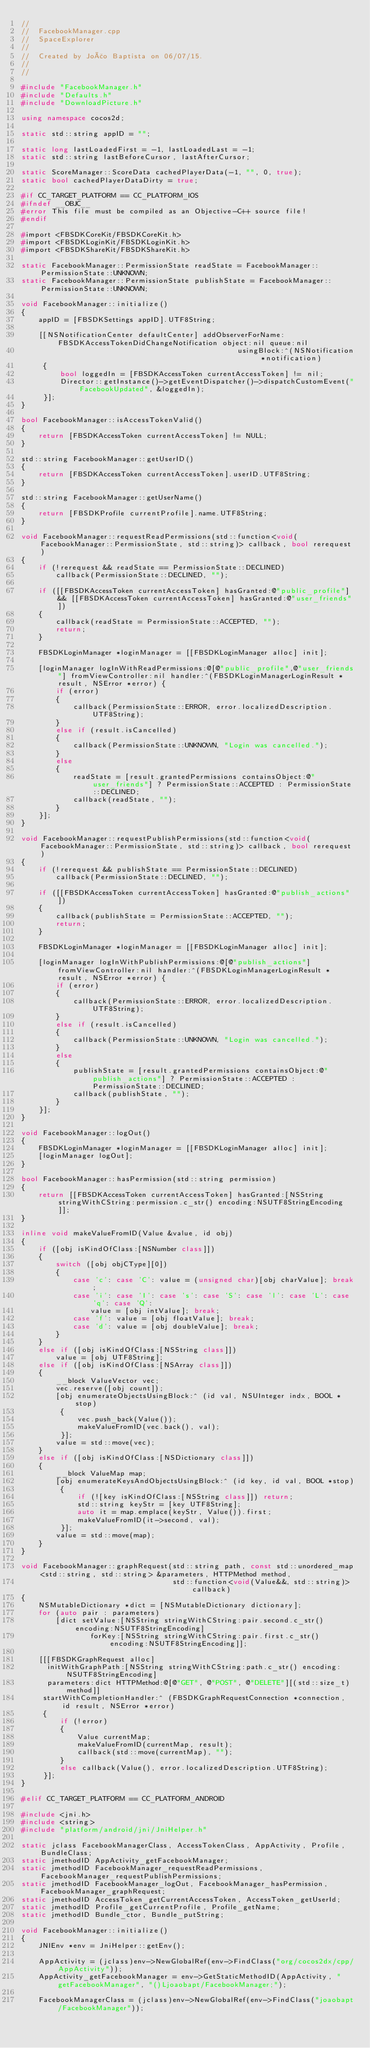Convert code to text. <code><loc_0><loc_0><loc_500><loc_500><_C++_>//
//  FacebookManager.cpp
//  SpaceExplorer
//
//  Created by João Baptista on 06/07/15.
//
//

#include "FacebookManager.h"
#include "Defaults.h"
#include "DownloadPicture.h"

using namespace cocos2d;

static std::string appID = "";

static long lastLoadedFirst = -1, lastLoadedLast = -1;
static std::string lastBeforeCursor, lastAfterCursor;

static ScoreManager::ScoreData cachedPlayerData(-1, "", 0, true);
static bool cachedPlayerDataDirty = true;

#if CC_TARGET_PLATFORM == CC_PLATFORM_IOS
#ifndef __OBJC__
#error This file must be compiled as an Objective-C++ source file!
#endif

#import <FBSDKCoreKit/FBSDKCoreKit.h>
#import <FBSDKLoginKit/FBSDKLoginKit.h>
#import <FBSDKShareKit/FBSDKShareKit.h>

static FacebookManager::PermissionState readState = FacebookManager::PermissionState::UNKNOWN;
static FacebookManager::PermissionState publishState = FacebookManager::PermissionState::UNKNOWN;

void FacebookManager::initialize()
{
    appID = [FBSDKSettings appID].UTF8String;
    
    [[NSNotificationCenter defaultCenter] addObserverForName:FBSDKAccessTokenDidChangeNotification object:nil queue:nil
                                                  usingBlock:^(NSNotification *notification)
     {
         bool loggedIn = [FBSDKAccessToken currentAccessToken] != nil;
         Director::getInstance()->getEventDispatcher()->dispatchCustomEvent("FacebookUpdated", &loggedIn);
     }];
}

bool FacebookManager::isAccessTokenValid()
{
    return [FBSDKAccessToken currentAccessToken] != NULL;
}

std::string FacebookManager::getUserID()
{
    return [FBSDKAccessToken currentAccessToken].userID.UTF8String;
}

std::string FacebookManager::getUserName()
{
    return [FBSDKProfile currentProfile].name.UTF8String;
}

void FacebookManager::requestReadPermissions(std::function<void(FacebookManager::PermissionState, std::string)> callback, bool rerequest)
{
    if (!rerequest && readState == PermissionState::DECLINED)
        callback(PermissionState::DECLINED, "");
    
    if ([[FBSDKAccessToken currentAccessToken] hasGranted:@"public_profile"] && [[FBSDKAccessToken currentAccessToken] hasGranted:@"user_friends"])
    {
        callback(readState = PermissionState::ACCEPTED, "");
        return;
    }
    
    FBSDKLoginManager *loginManager = [[FBSDKLoginManager alloc] init];
    
    [loginManager logInWithReadPermissions:@[@"public_profile",@"user_friends"] fromViewController:nil handler:^(FBSDKLoginManagerLoginResult *result, NSError *error) {
        if (error)
        {
            callback(PermissionState::ERROR, error.localizedDescription.UTF8String);
        }
        else if (result.isCancelled)
        {
            callback(PermissionState::UNKNOWN, "Login was cancelled.");
        }
        else
        {
            readState = [result.grantedPermissions containsObject:@"user_friends"] ? PermissionState::ACCEPTED : PermissionState::DECLINED;
            callback(readState, "");
        }
    }];
}

void FacebookManager::requestPublishPermissions(std::function<void(FacebookManager::PermissionState, std::string)> callback, bool rerequest)
{
    if (!rerequest && publishState == PermissionState::DECLINED)
        callback(PermissionState::DECLINED, "");
    
    if ([[FBSDKAccessToken currentAccessToken] hasGranted:@"publish_actions"])
    {
        callback(publishState = PermissionState::ACCEPTED, "");
        return;
    }
    
    FBSDKLoginManager *loginManager = [[FBSDKLoginManager alloc] init];
    
    [loginManager logInWithPublishPermissions:@[@"publish_actions"] fromViewController:nil handler:^(FBSDKLoginManagerLoginResult *result, NSError *error) {
        if (error)
        {
            callback(PermissionState::ERROR, error.localizedDescription.UTF8String);
        }
        else if (result.isCancelled)
        {
            callback(PermissionState::UNKNOWN, "Login was cancelled.");
        }
        else
        {
            publishState = [result.grantedPermissions containsObject:@"publish_actions"] ? PermissionState::ACCEPTED : PermissionState::DECLINED;
            callback(publishState, "");
        }
    }];
}

void FacebookManager::logOut()
{
    FBSDKLoginManager *loginManager = [[FBSDKLoginManager alloc] init];
    [loginManager logOut];
}

bool FacebookManager::hasPermission(std::string permission)
{
    return [[FBSDKAccessToken currentAccessToken] hasGranted:[NSString stringWithCString:permission.c_str() encoding:NSUTF8StringEncoding]];
}

inline void makeValueFromID(Value &value, id obj)
{
    if ([obj isKindOfClass:[NSNumber class]])
    {
        switch ([obj objCType][0])
        {
            case 'c': case 'C': value = (unsigned char)[obj charValue]; break;
            case 'i': case 'I': case 's': case 'S': case 'l': case 'L': case 'q': case 'Q':
                value = [obj intValue]; break;
            case 'f': value = [obj floatValue]; break;
            case 'd': value = [obj doubleValue]; break;
        }
    }
    else if ([obj isKindOfClass:[NSString class]])
        value = [obj UTF8String];
    else if ([obj isKindOfClass:[NSArray class]])
    {
        __block ValueVector vec;
        vec.reserve([obj count]);
        [obj enumerateObjectsUsingBlock:^ (id val, NSUInteger indx, BOOL *stop)
         {
			 vec.push_back(Value());
             makeValueFromID(vec.back(), val);
         }];
        value = std::move(vec);
    }
    else if ([obj isKindOfClass:[NSDictionary class]])
    {
        __block ValueMap map;
        [obj enumerateKeysAndObjectsUsingBlock:^ (id key, id val, BOOL *stop)
         {
             if (![key isKindOfClass:[NSString class]]) return;
             std::string keyStr = [key UTF8String];
             auto it = map.emplace(keyStr, Value()).first;
             makeValueFromID(it->second, val);
         }];
        value = std::move(map);
    }
}

void FacebookManager::graphRequest(std::string path, const std::unordered_map<std::string, std::string> &parameters, HTTPMethod method,
                                   std::function<void(Value&&, std::string)> callback)
{
    NSMutableDictionary *dict = [NSMutableDictionary dictionary];
    for (auto pair : parameters)
        [dict setValue:[NSString stringWithCString:pair.second.c_str() encoding:NSUTF8StringEncoding]
                forKey:[NSString stringWithCString:pair.first.c_str() encoding:NSUTF8StringEncoding]];
    
    [[[FBSDKGraphRequest alloc]
      initWithGraphPath:[NSString stringWithCString:path.c_str() encoding:NSUTF8StringEncoding]
      parameters:dict HTTPMethod:@[@"GET", @"POST", @"DELETE"][(std::size_t)method]]
     startWithCompletionHandler:^ (FBSDKGraphRequestConnection *connection, id result, NSError *error)
     {
         if (!error)
         {
             Value currentMap;
             makeValueFromID(currentMap, result);
             callback(std::move(currentMap), "");
         }
         else callback(Value(), error.localizedDescription.UTF8String);
     }];
}

#elif CC_TARGET_PLATFORM == CC_PLATFORM_ANDROID

#include <jni.h>
#include <string>
#include "platform/android/jni/JniHelper.h"

static jclass FacebookManagerClass, AccessTokenClass, AppActivity, Profile, BundleClass;
static jmethodID AppActivity_getFacebookManager;
static jmethodID FacebookManager_requestReadPermissions, FacebookManager_requestPublishPermissions;
static jmethodID FacebookManager_logOut, FacebookManager_hasPermission, FacebookManager_graphRequest;
static jmethodID AccessToken_getCurrentAccessToken, AccessToken_getUserId;
static jmethodID Profile_getCurrentProfile, Profile_getName;
static jmethodID Bundle_ctor, Bundle_putString;

void FacebookManager::initialize()
{
    JNIEnv *env = JniHelper::getEnv();
    
    AppActivity = (jclass)env->NewGlobalRef(env->FindClass("org/cocos2dx/cpp/AppActivity"));
    AppActivity_getFacebookManager = env->GetStaticMethodID(AppActivity, "getFacebookManager", "()Ljoaobapt/FacebookManager;");
    
    FacebookManagerClass = (jclass)env->NewGlobalRef(env->FindClass("joaobapt/FacebookManager"));</code> 